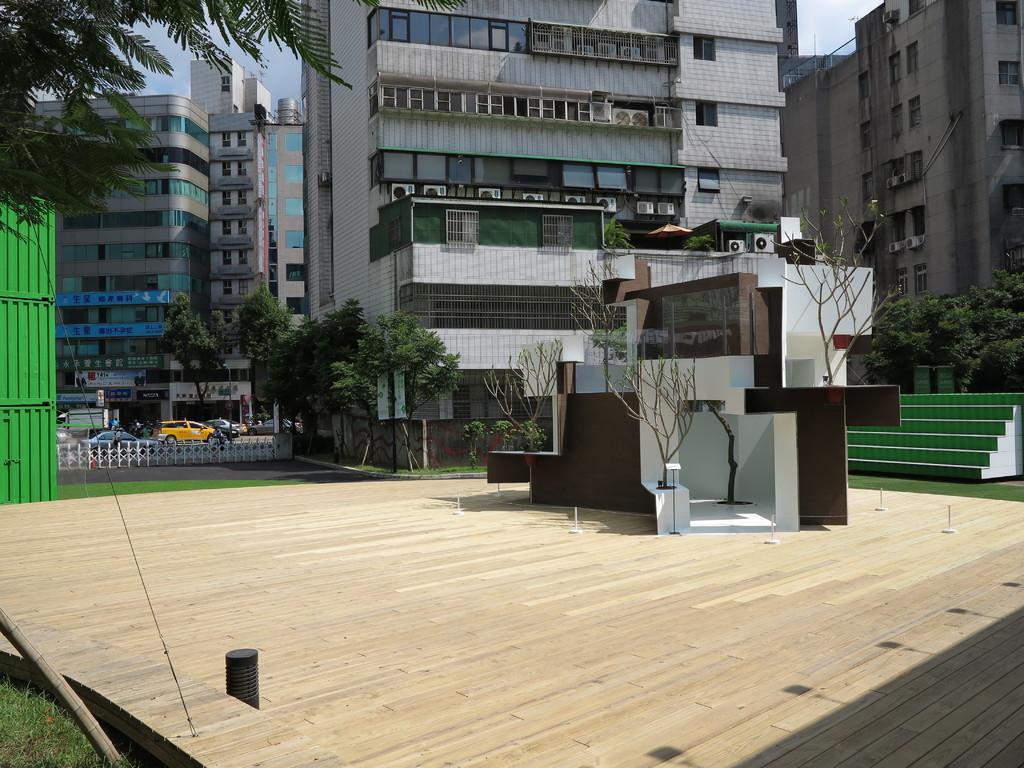In one or two sentences, can you explain what this image depicts? This image consists of many buildings along with windows. At the bottom, there is a wooden floor. On the left, there is a tree. In the front, we can see the vehicles. At the top, there is a sky. 